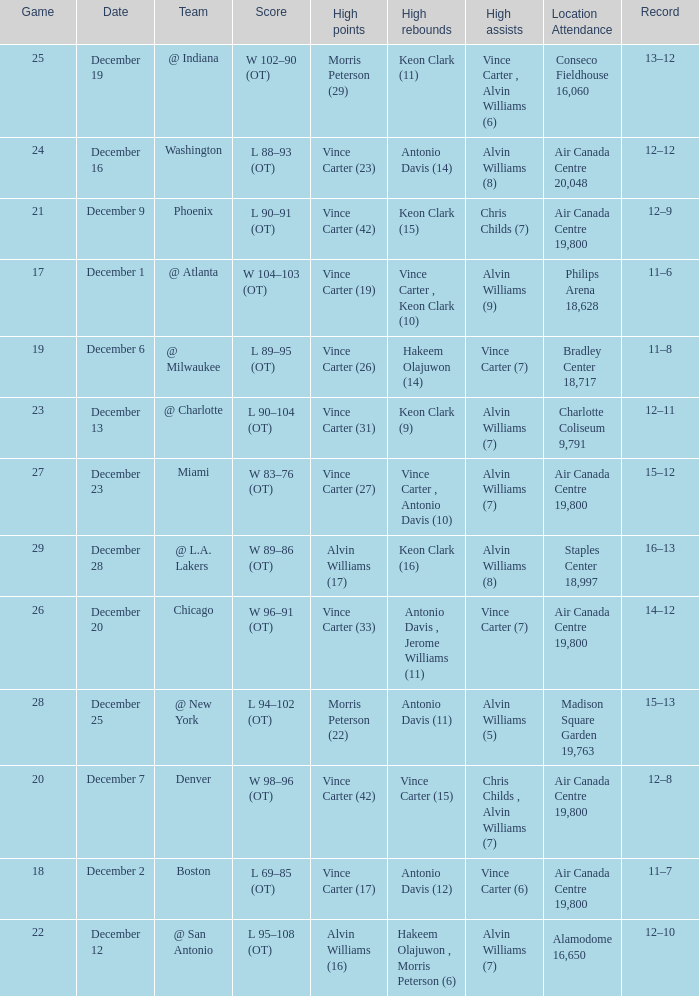What game happened on December 19? 25.0. 